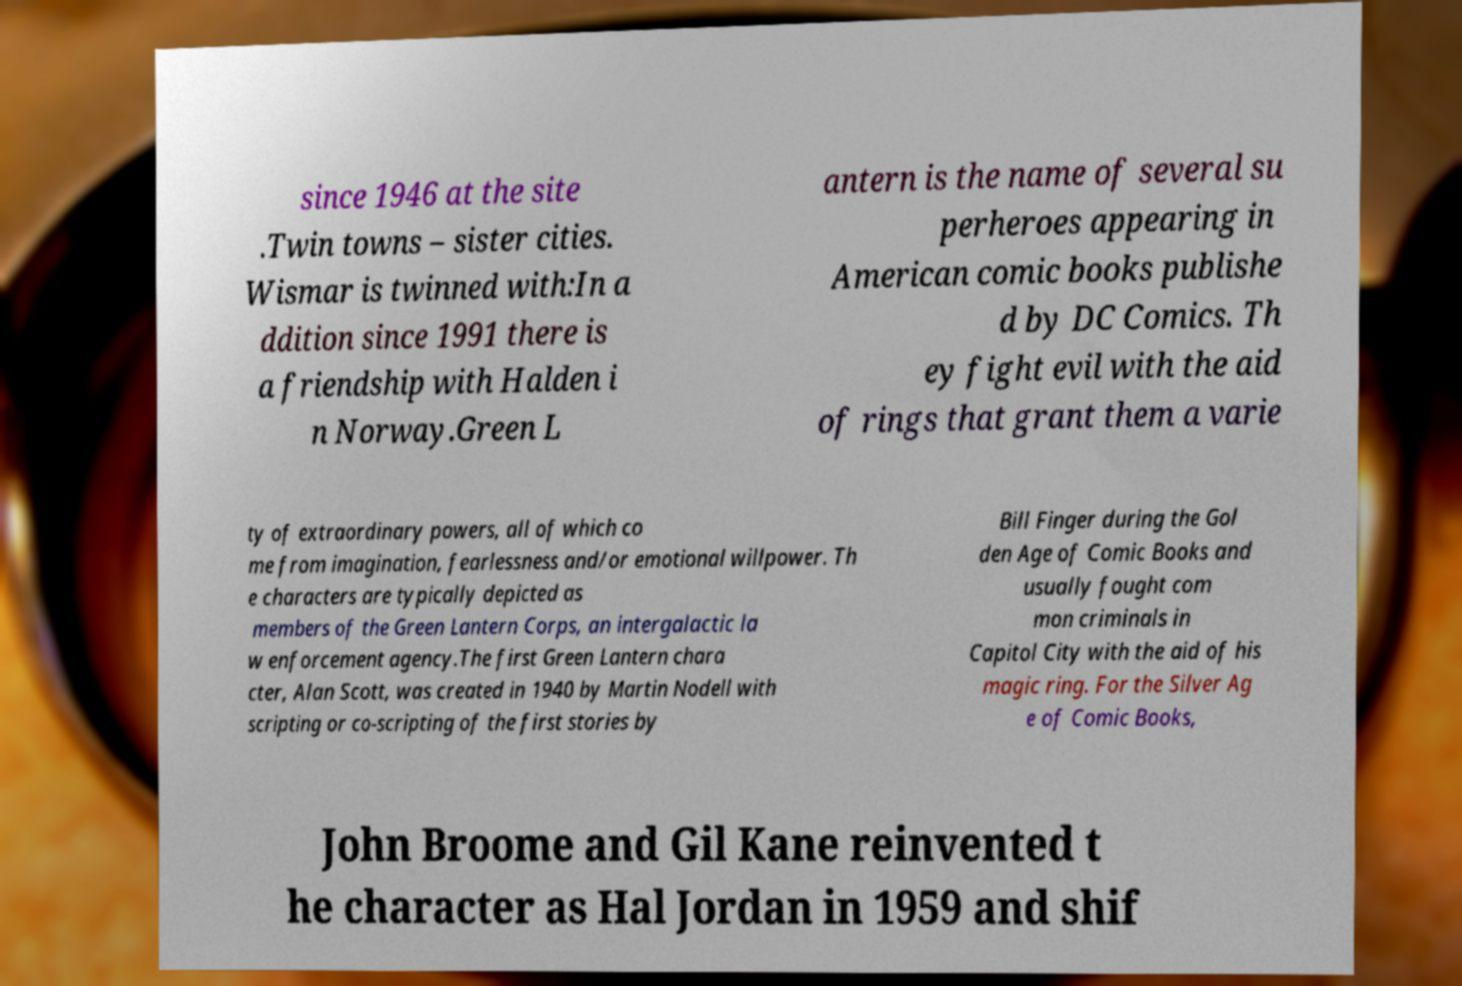What messages or text are displayed in this image? I need them in a readable, typed format. since 1946 at the site .Twin towns – sister cities. Wismar is twinned with:In a ddition since 1991 there is a friendship with Halden i n Norway.Green L antern is the name of several su perheroes appearing in American comic books publishe d by DC Comics. Th ey fight evil with the aid of rings that grant them a varie ty of extraordinary powers, all of which co me from imagination, fearlessness and/or emotional willpower. Th e characters are typically depicted as members of the Green Lantern Corps, an intergalactic la w enforcement agency.The first Green Lantern chara cter, Alan Scott, was created in 1940 by Martin Nodell with scripting or co-scripting of the first stories by Bill Finger during the Gol den Age of Comic Books and usually fought com mon criminals in Capitol City with the aid of his magic ring. For the Silver Ag e of Comic Books, John Broome and Gil Kane reinvented t he character as Hal Jordan in 1959 and shif 